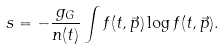<formula> <loc_0><loc_0><loc_500><loc_500>s = - \frac { g _ { G } } { n ( t ) } \int f ( t , \vec { p } ) \log f ( t , \vec { p } ) .</formula> 